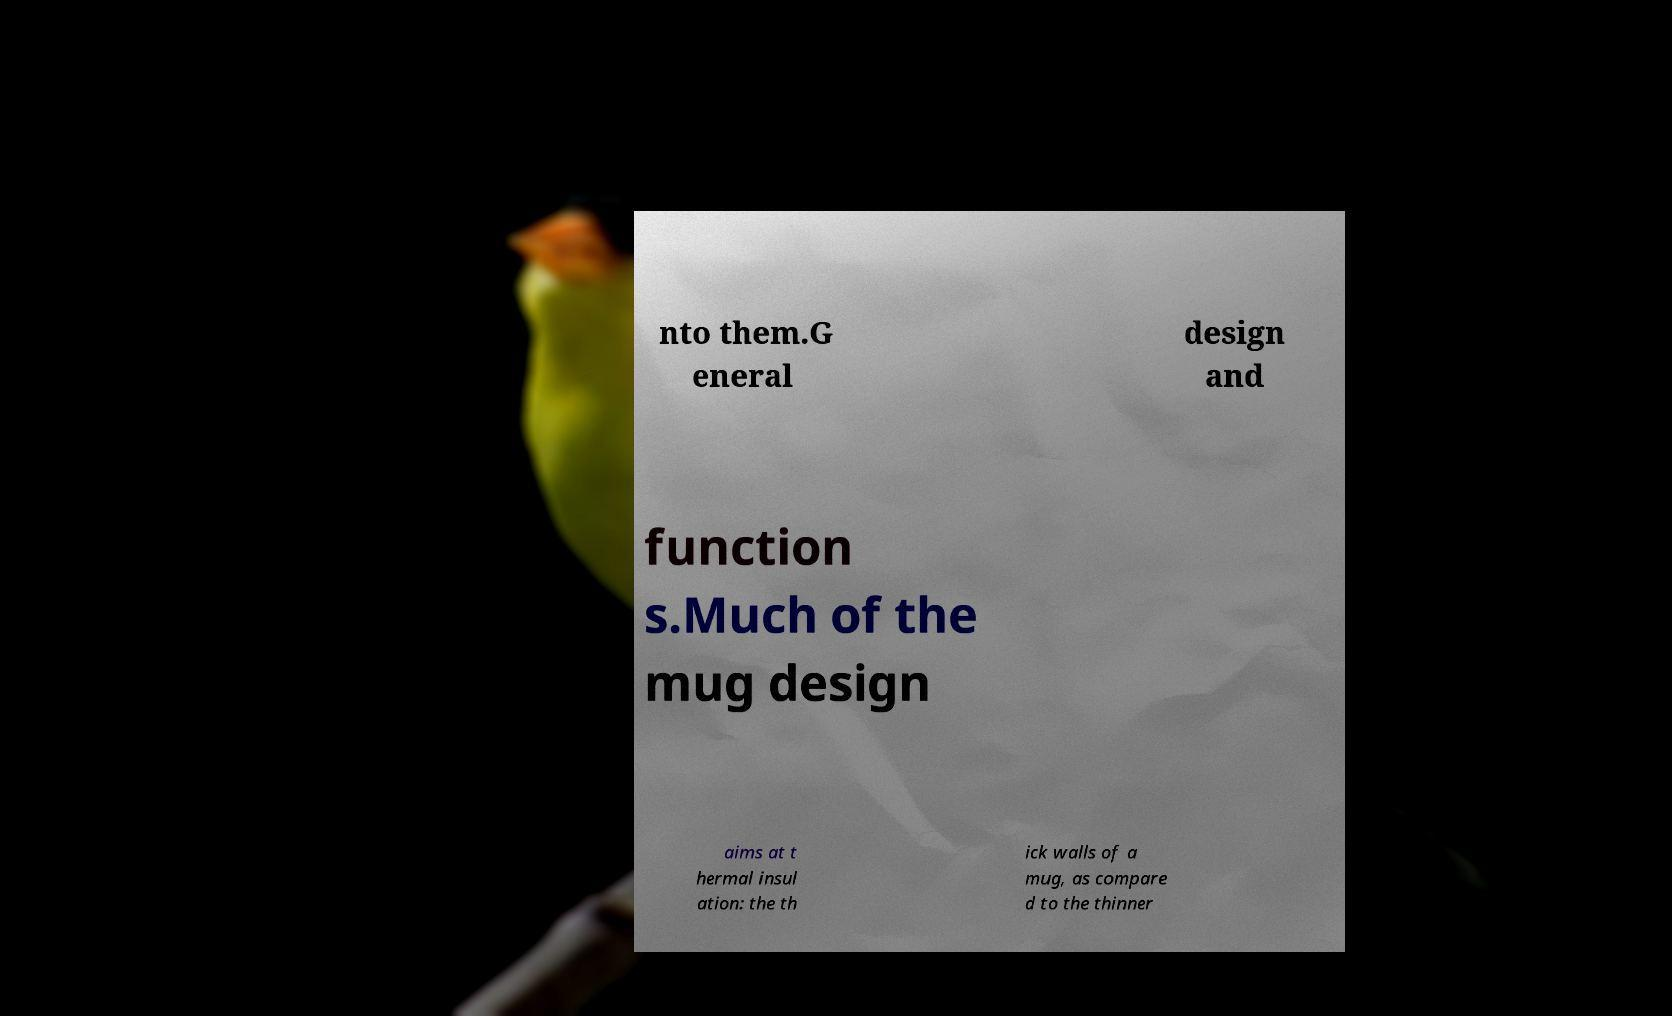For documentation purposes, I need the text within this image transcribed. Could you provide that? nto them.G eneral design and function s.Much of the mug design aims at t hermal insul ation: the th ick walls of a mug, as compare d to the thinner 